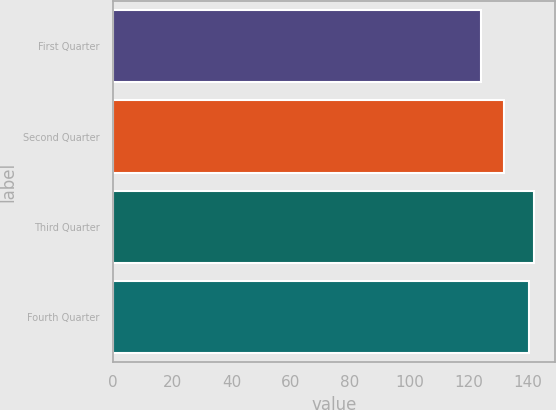Convert chart. <chart><loc_0><loc_0><loc_500><loc_500><bar_chart><fcel>First Quarter<fcel>Second Quarter<fcel>Third Quarter<fcel>Fourth Quarter<nl><fcel>123.99<fcel>131.99<fcel>142<fcel>140.27<nl></chart> 